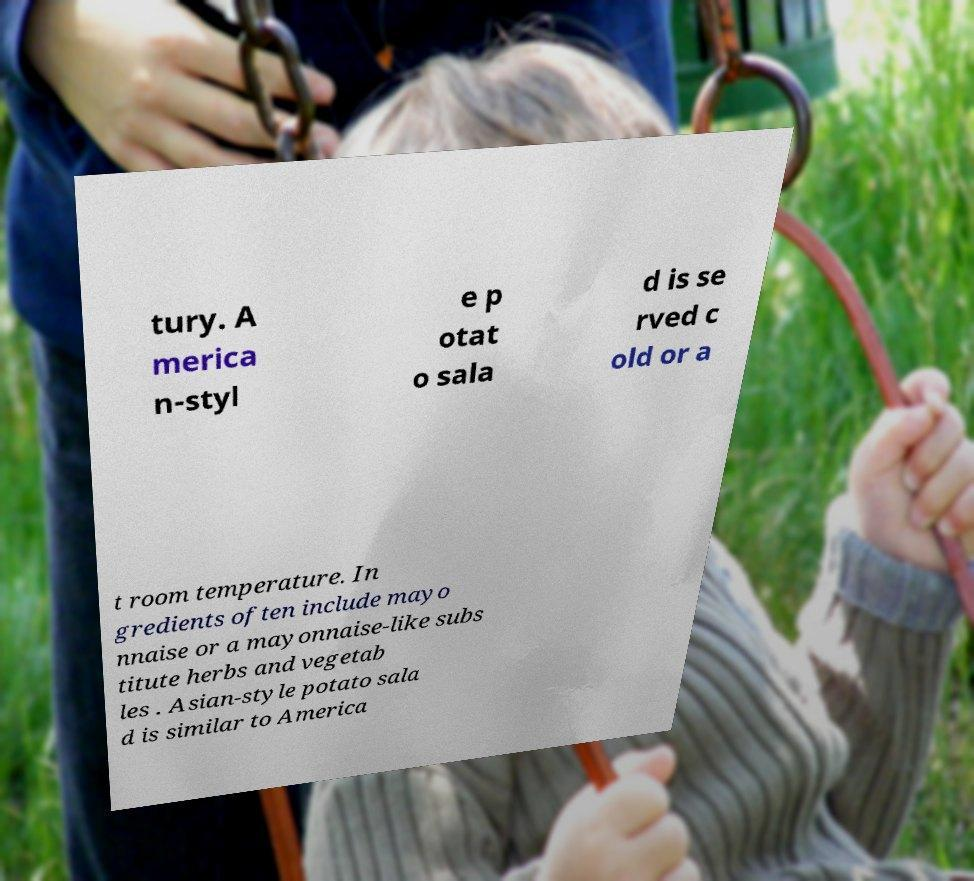Please identify and transcribe the text found in this image. tury. A merica n-styl e p otat o sala d is se rved c old or a t room temperature. In gredients often include mayo nnaise or a mayonnaise-like subs titute herbs and vegetab les . Asian-style potato sala d is similar to America 